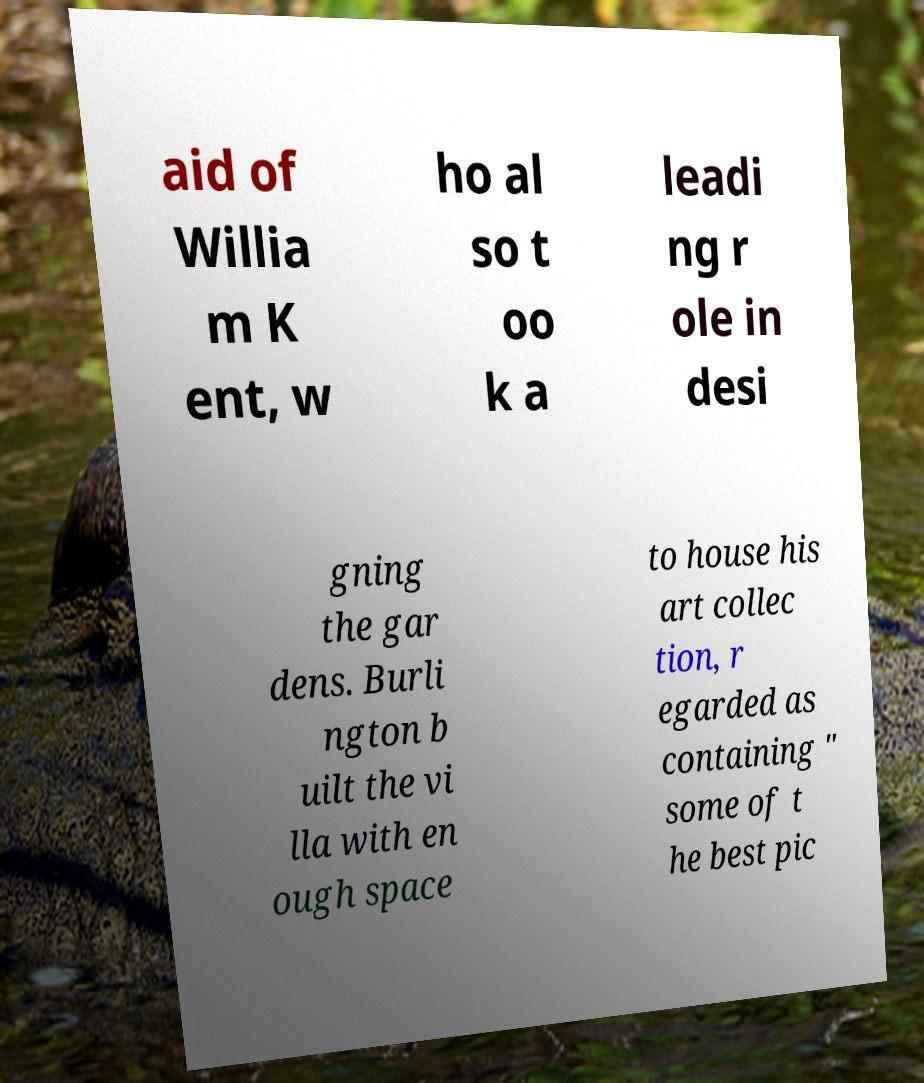What messages or text are displayed in this image? I need them in a readable, typed format. aid of Willia m K ent, w ho al so t oo k a leadi ng r ole in desi gning the gar dens. Burli ngton b uilt the vi lla with en ough space to house his art collec tion, r egarded as containing " some of t he best pic 